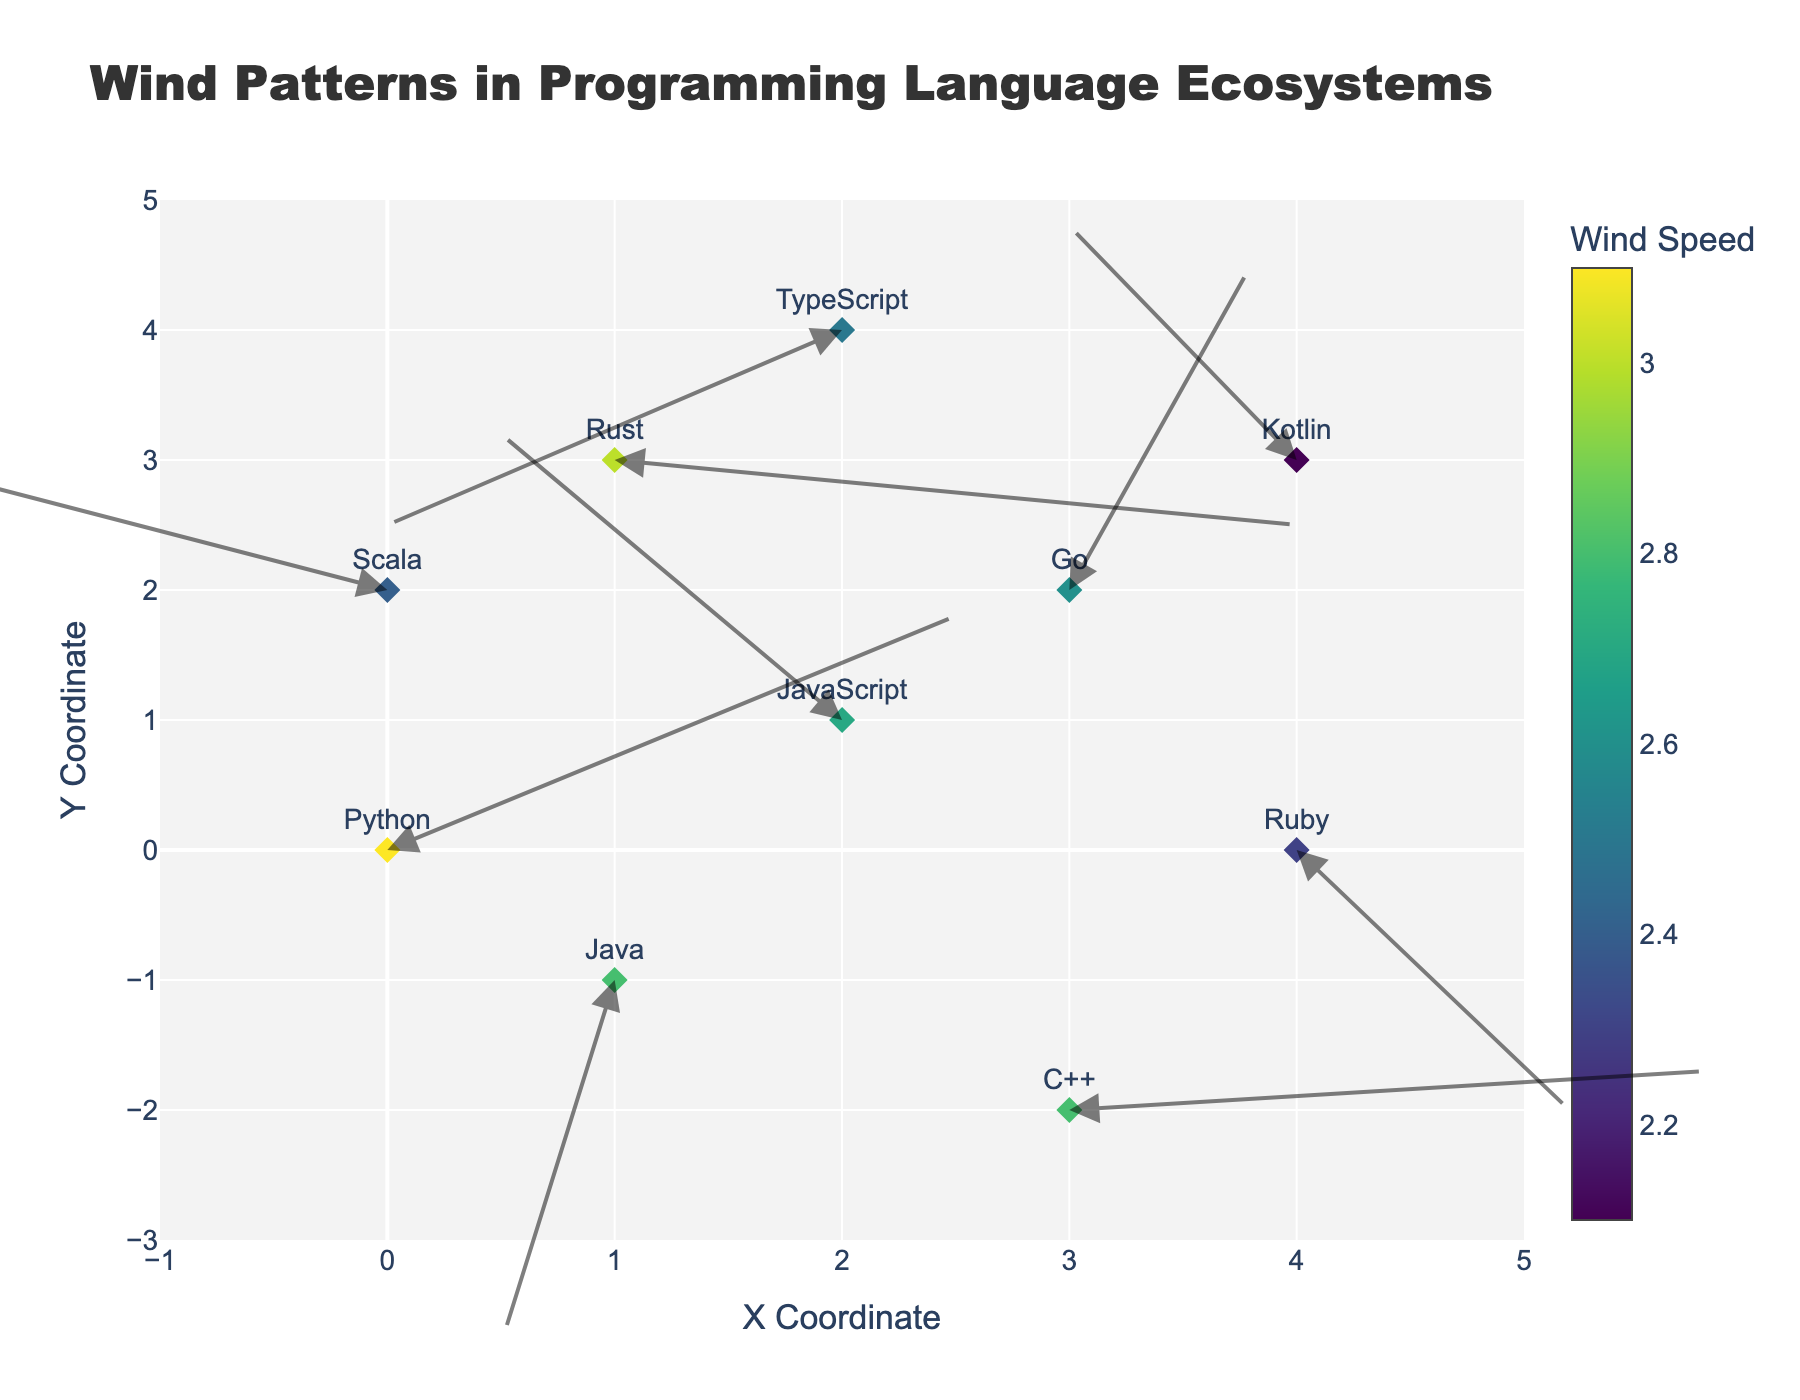How many programming languages are represented in this figure? Count the unique values in the 'language' column. Each row represents a different programming language.
Answer: 10 What is the title of the figure? Look at the top area of the figure, which typically contains the title.
Answer: Wind Patterns in Programming Language Ecosystems Which language has the highest wind speed? Examine the color intensity and the colorbar legend, which correlates color with wind speed. The darkest shade typically indicates the highest magnitude. Python has the highest magnitude (3.1).
Answer: Python What are the x and y coordinates for the Ruby wind vector? Locate the Ruby data point on the figure and read its x and y positions. Ruby's coordinates are at (4, 0).
Answer: (4, 0) Which data point shows the largest upward wind pattern? Identify the vector with the largest positive y-component (v). Java, with coordinates (1, -1), has the largest upward movement (v = -2.8).
Answer: Java Compare the wind vector directions of Scala and TypeScript. Which has a more negative x component? Observe the u components of both vectors. Scala has u = -2.2 and TypeScript has u = -2.0.
Answer: Scala What is the combined wind speed magnitude of Java and C++? Add the magnitudes of Java and C++ from the data (2.8 + 2.8).
Answer: 5.6 Which language has the most downward direction in its wind vector? Look for the vector with the largest negative y-component (v). Java has the largest negative y-component (-2.8).
Answer: Java In what direction is the Rust wind vector pointing? Evaluate the signs and relative magnitudes of the u and v components of the Rust vector (u=3.0, v=-0.5). The vector points rightward and slightly downward.
Answer: Rightward and slightly downward If you average the x and y coordinates of Python and JavaScript, what is the resulting coordinate? Calculate the average by adding their x and y coordinates and dividing by 2: ((0 + 2)/2, (0 + 1)/2) = (1, 0.5).
Answer: (1, 0.5) 